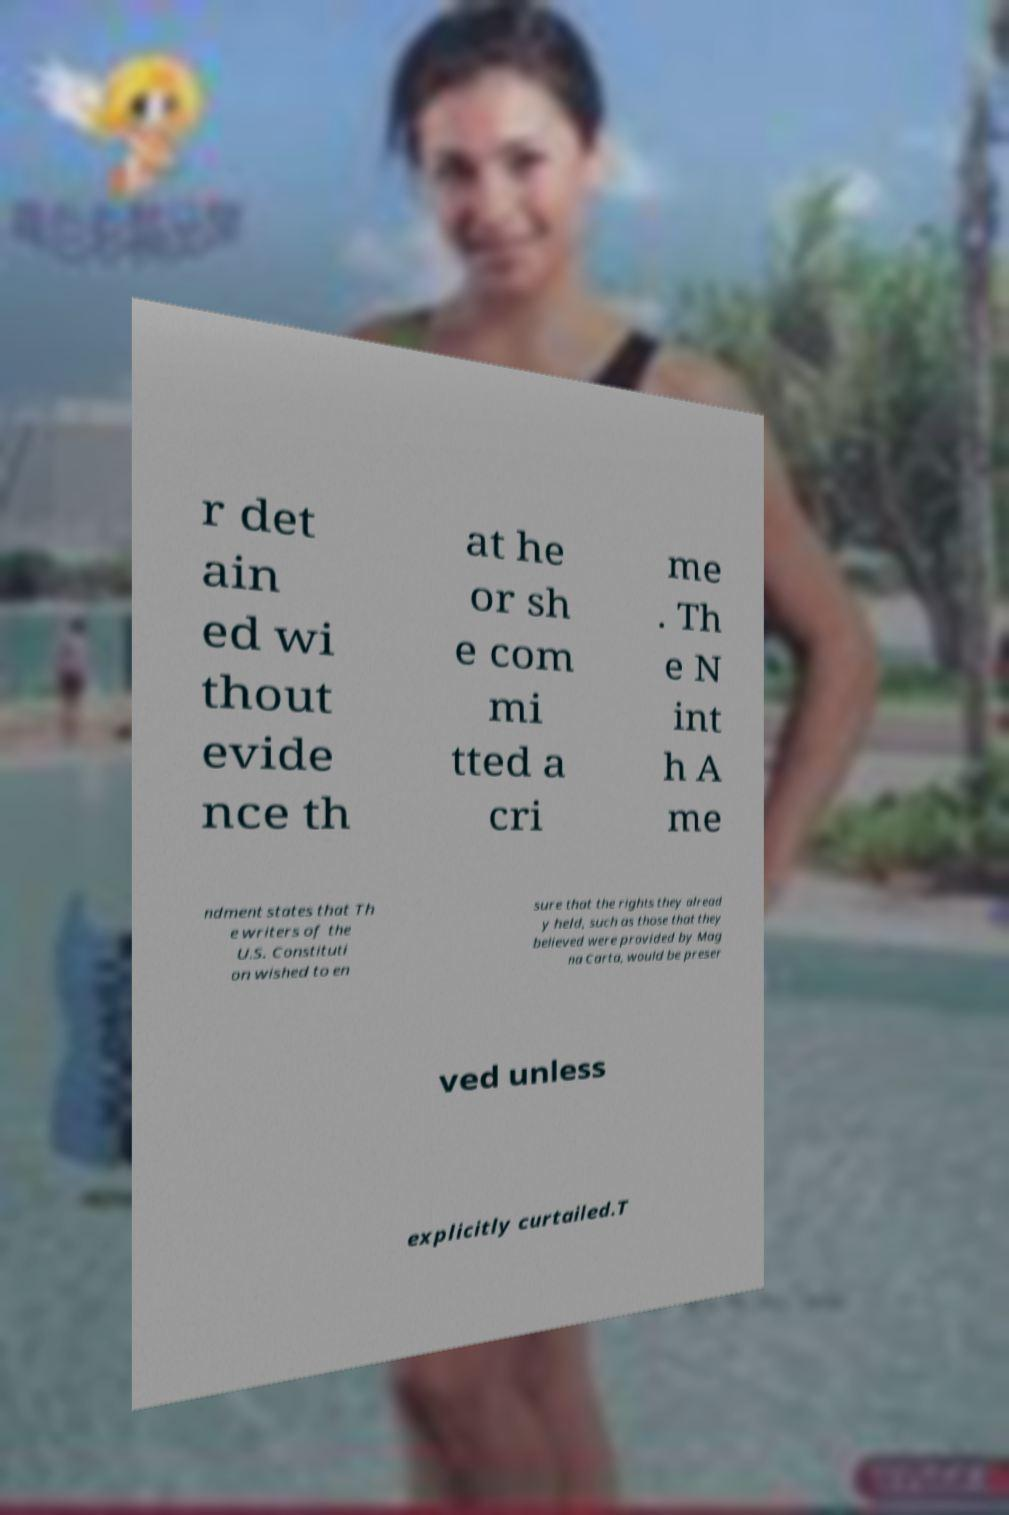Can you read and provide the text displayed in the image?This photo seems to have some interesting text. Can you extract and type it out for me? r det ain ed wi thout evide nce th at he or sh e com mi tted a cri me . Th e N int h A me ndment states that Th e writers of the U.S. Constituti on wished to en sure that the rights they alread y held, such as those that they believed were provided by Mag na Carta, would be preser ved unless explicitly curtailed.T 